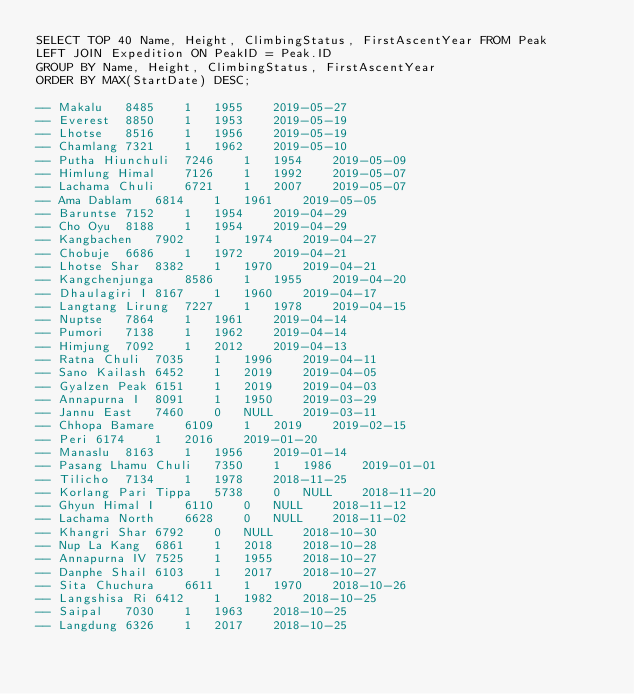<code> <loc_0><loc_0><loc_500><loc_500><_SQL_>SELECT TOP 40 Name, Height, ClimbingStatus, FirstAscentYear FROM Peak
LEFT JOIN Expedition ON PeakID = Peak.ID
GROUP BY Name, Height, ClimbingStatus, FirstAscentYear
ORDER BY MAX(StartDate) DESC;

-- Makalu	8485	1	1955	2019-05-27
-- Everest	8850	1	1953	2019-05-19
-- Lhotse	8516	1	1956	2019-05-19
-- Chamlang	7321	1	1962	2019-05-10
-- Putha Hiunchuli	7246	1	1954	2019-05-09
-- Himlung Himal	7126	1	1992	2019-05-07
-- Lachama Chuli	6721	1	2007	2019-05-07
-- Ama Dablam	6814	1	1961	2019-05-05
-- Baruntse	7152	1	1954	2019-04-29
-- Cho Oyu	8188	1	1954	2019-04-29
-- Kangbachen	7902	1	1974	2019-04-27
-- Chobuje	6686	1	1972	2019-04-21
-- Lhotse Shar	8382	1	1970	2019-04-21
-- Kangchenjunga	8586	1	1955	2019-04-20
-- Dhaulagiri I	8167	1	1960	2019-04-17
-- Langtang Lirung	7227	1	1978	2019-04-15
-- Nuptse	7864	1	1961	2019-04-14
-- Pumori	7138	1	1962	2019-04-14
-- Himjung	7092	1	2012	2019-04-13
-- Ratna Chuli	7035	1	1996	2019-04-11
-- Sano Kailash	6452	1	2019	2019-04-05
-- Gyalzen Peak	6151	1	2019	2019-04-03
-- Annapurna I	8091	1	1950	2019-03-29
-- Jannu East	7460	0	NULL	2019-03-11
-- Chhopa Bamare	6109	1	2019	2019-02-15
-- Peri	6174	1	2016	2019-01-20
-- Manaslu	8163	1	1956	2019-01-14
-- Pasang Lhamu Chuli	7350	1	1986	2019-01-01
-- Tilicho	7134	1	1978	2018-11-25
-- Korlang Pari Tippa	5738	0	NULL	2018-11-20
-- Ghyun Himal I	6110	0	NULL	2018-11-12
-- Lachama North	6628	0	NULL	2018-11-02
-- Khangri Shar	6792	0	NULL	2018-10-30
-- Nup La Kang	6861	1	2018	2018-10-28
-- Annapurna IV	7525	1	1955	2018-10-27
-- Danphe Shail	6103	1	2017	2018-10-27
-- Sita Chuchura	6611	1	1970	2018-10-26
-- Langshisa Ri	6412	1	1982	2018-10-25
-- Saipal	7030	1	1963	2018-10-25
-- Langdung	6326	1	2017	2018-10-25</code> 